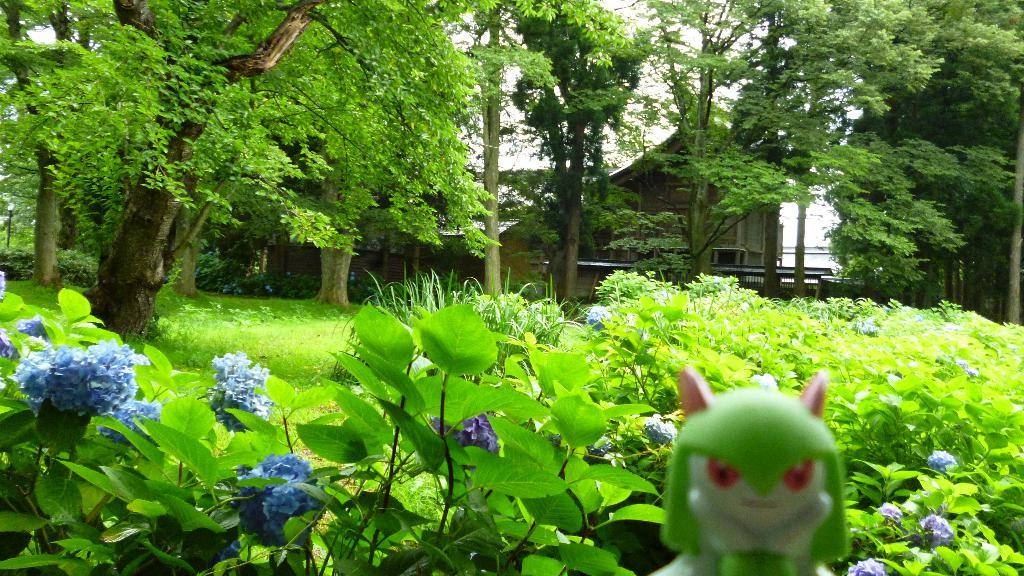What type of natural elements are present in the image? There are trees and plants in the image. What color are the trees and plants? The trees and plants are in green color. What other object can be seen in the image? There is a toy in the image. What colors are used for the toy? The toy is in white and green color. What can be seen in the background of the image? The sky is visible in the background of the image. What color is the sky? The sky is in white color. Can you tell me where the father is standing in the image? There is no father present in the image. What type of border is visible in the image? There is no border visible in the image. What kind of battle is taking place in the image? There is no battle depicted in the image. 